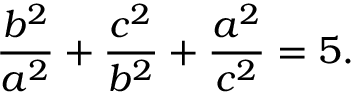Convert formula to latex. <formula><loc_0><loc_0><loc_500><loc_500>{ \frac { b ^ { 2 } } { a ^ { 2 } } } + { \frac { c ^ { 2 } } { b ^ { 2 } } } + { \frac { a ^ { 2 } } { c ^ { 2 } } } = 5 .</formula> 